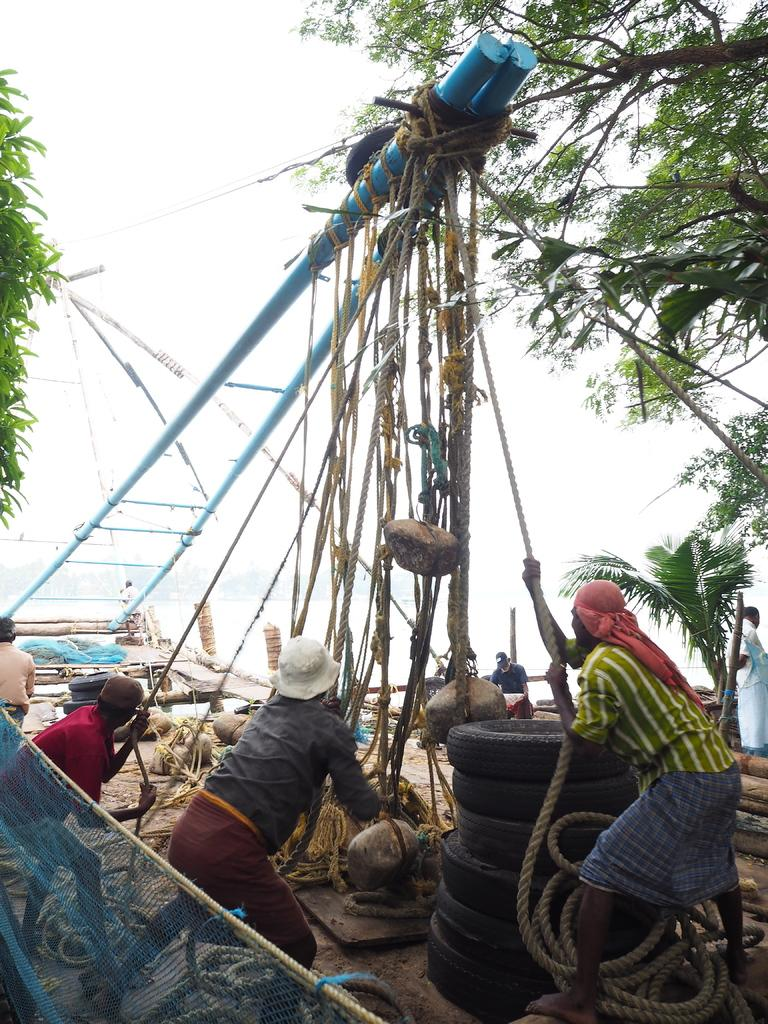What is the main subject of the image? The main subject of the image is a ship. What are some people on the ship doing? Some people on the ship are holding ropes. What can be seen in the background of the image? There are trees in the background. What other objects can be seen on the ship? There are rods or poles visible, as well as tires and a net. What type of terrain is visible in the image? There are rocks visible in the image. What type of skirt is being used as a sail in the image? There is no skirt present in the image, and therefore no such use can be observed. How many marks are visible on the ship's hull in the image? There is no mention of marks on the ship's hull in the provided facts, so it cannot be determined from the image. 